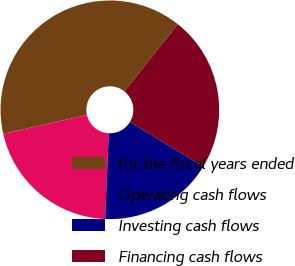<chart> <loc_0><loc_0><loc_500><loc_500><pie_chart><fcel>for the fiscal years ended<fcel>Operating cash flows<fcel>Investing cash flows<fcel>Financing cash flows<nl><fcel>39.21%<fcel>20.78%<fcel>17.02%<fcel>23.0%<nl></chart> 